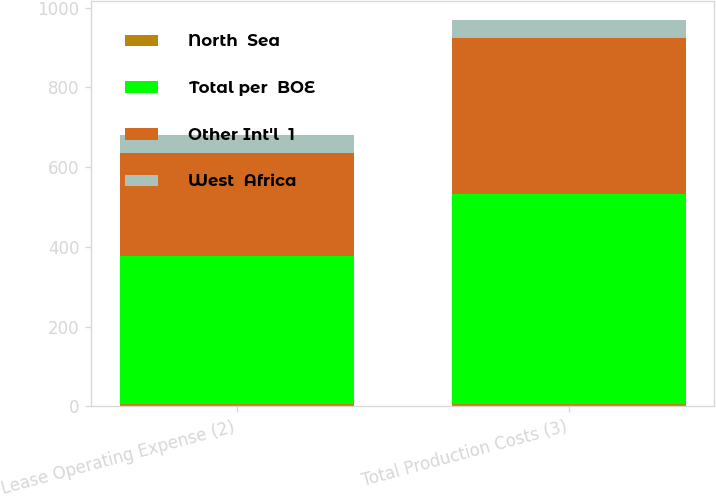Convert chart to OTSL. <chart><loc_0><loc_0><loc_500><loc_500><stacked_bar_chart><ecel><fcel>Lease Operating Expense (2)<fcel>Total Production Costs (3)<nl><fcel>North  Sea<fcel>5.05<fcel>7.13<nl><fcel>Total per  BOE<fcel>372<fcel>525<nl><fcel>Other Int'l  1<fcel>258<fcel>391<nl><fcel>West  Africa<fcel>45<fcel>45<nl></chart> 